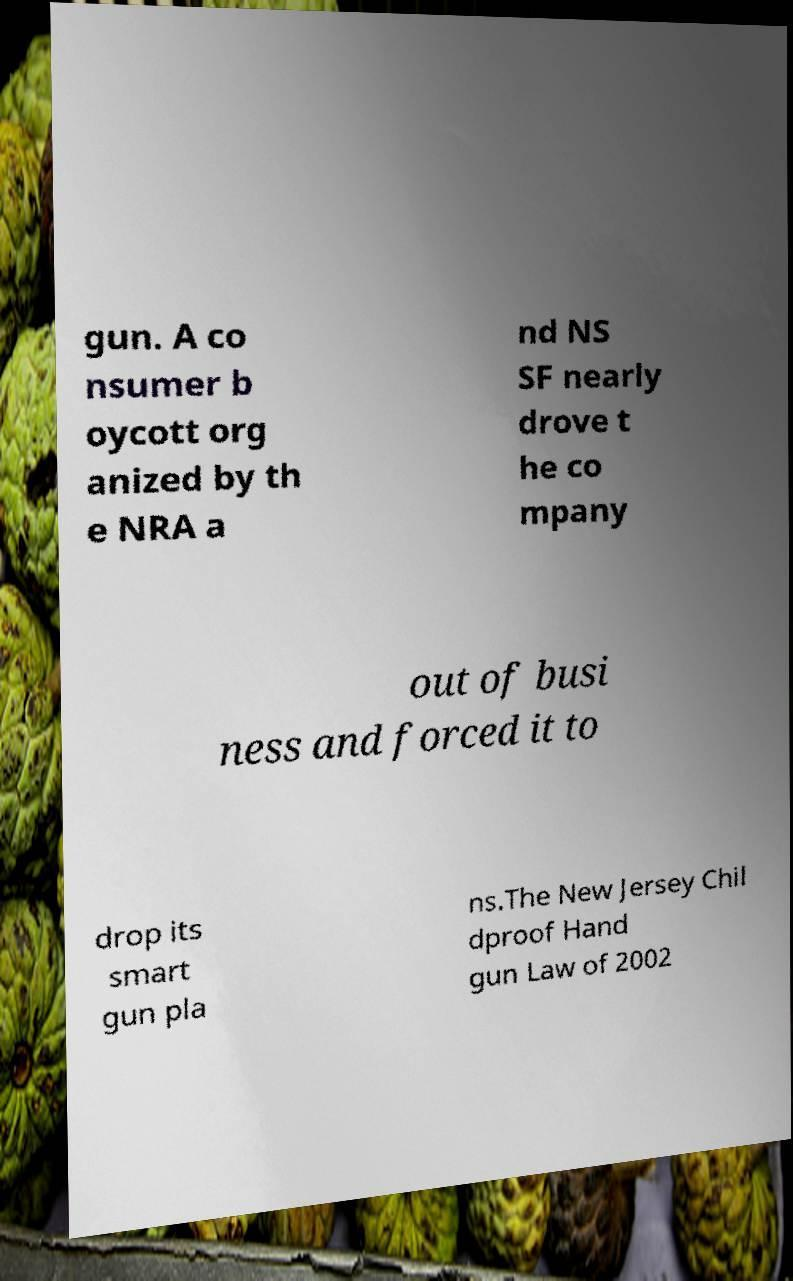I need the written content from this picture converted into text. Can you do that? gun. A co nsumer b oycott org anized by th e NRA a nd NS SF nearly drove t he co mpany out of busi ness and forced it to drop its smart gun pla ns.The New Jersey Chil dproof Hand gun Law of 2002 